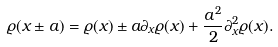Convert formula to latex. <formula><loc_0><loc_0><loc_500><loc_500>\varrho ( x \pm a ) = \varrho ( x ) \pm a \partial _ { x } \varrho ( x ) + \frac { a ^ { 2 } } { 2 } \partial _ { x } ^ { 2 } \varrho ( x ) .</formula> 